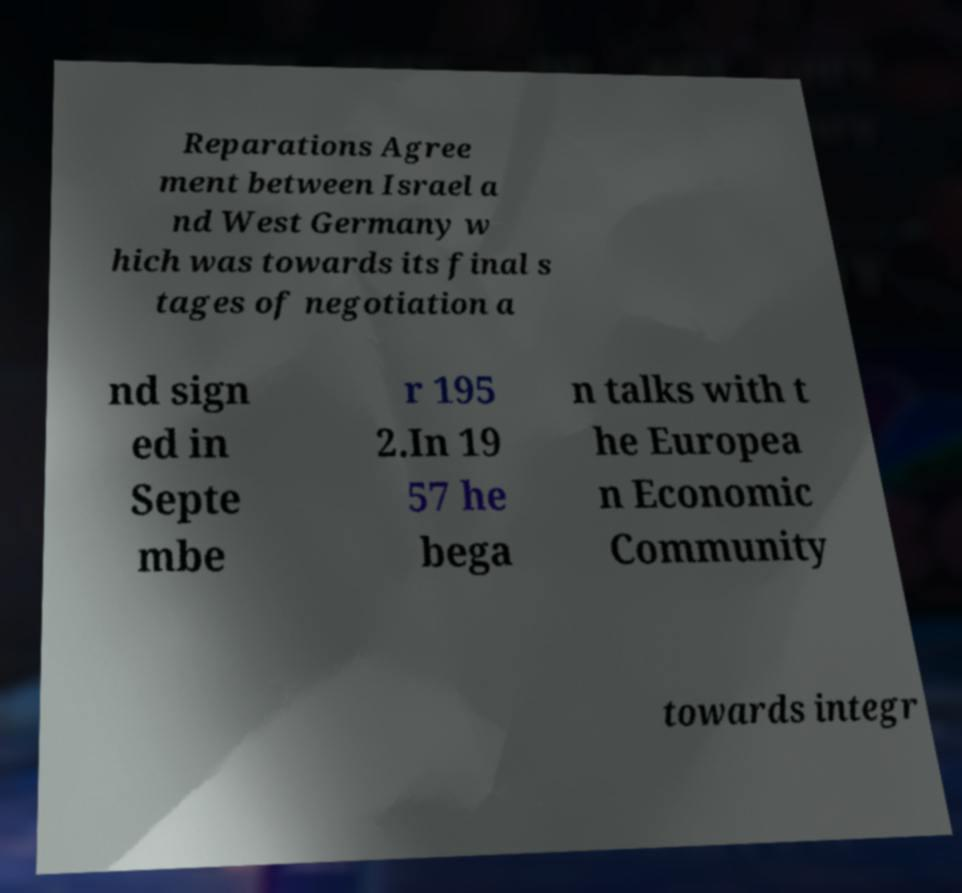I need the written content from this picture converted into text. Can you do that? Reparations Agree ment between Israel a nd West Germany w hich was towards its final s tages of negotiation a nd sign ed in Septe mbe r 195 2.In 19 57 he bega n talks with t he Europea n Economic Community towards integr 